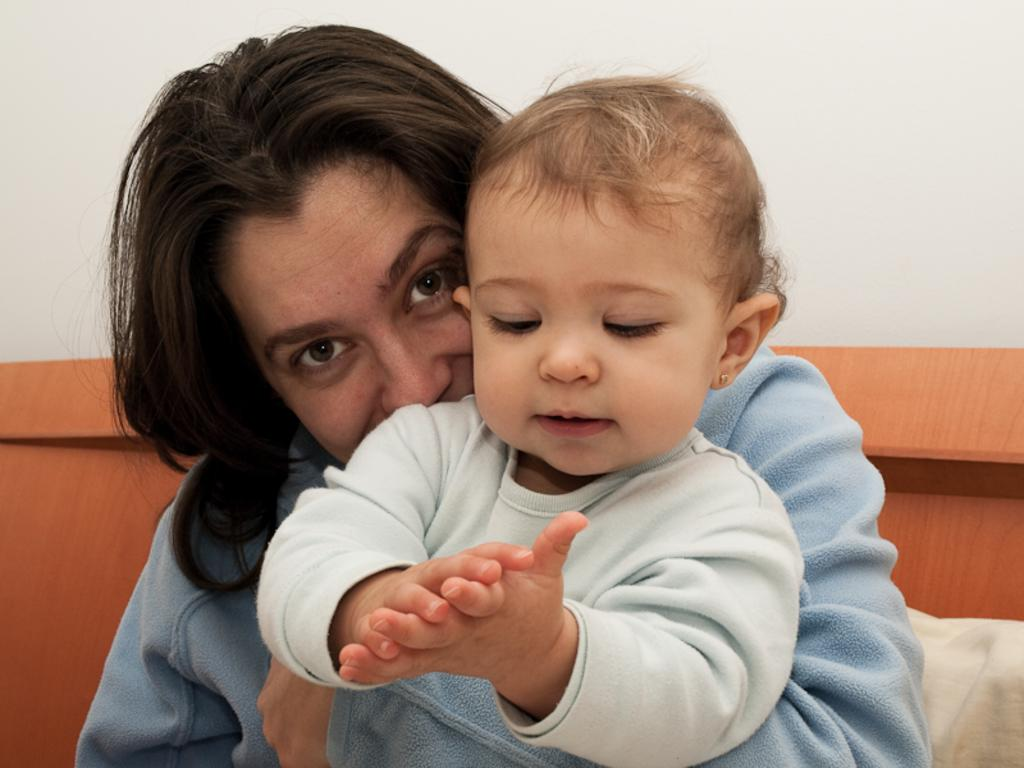Who is the main subject in the image? There is a woman in the image. What is the woman doing in the image? The woman is holding a baby. What can be seen in the background of the image? There is a wooden board, cloth, and a white wall visible in the background. What type of music can be heard playing in the background of the image? There is no music present in the image; it is a still photograph. 